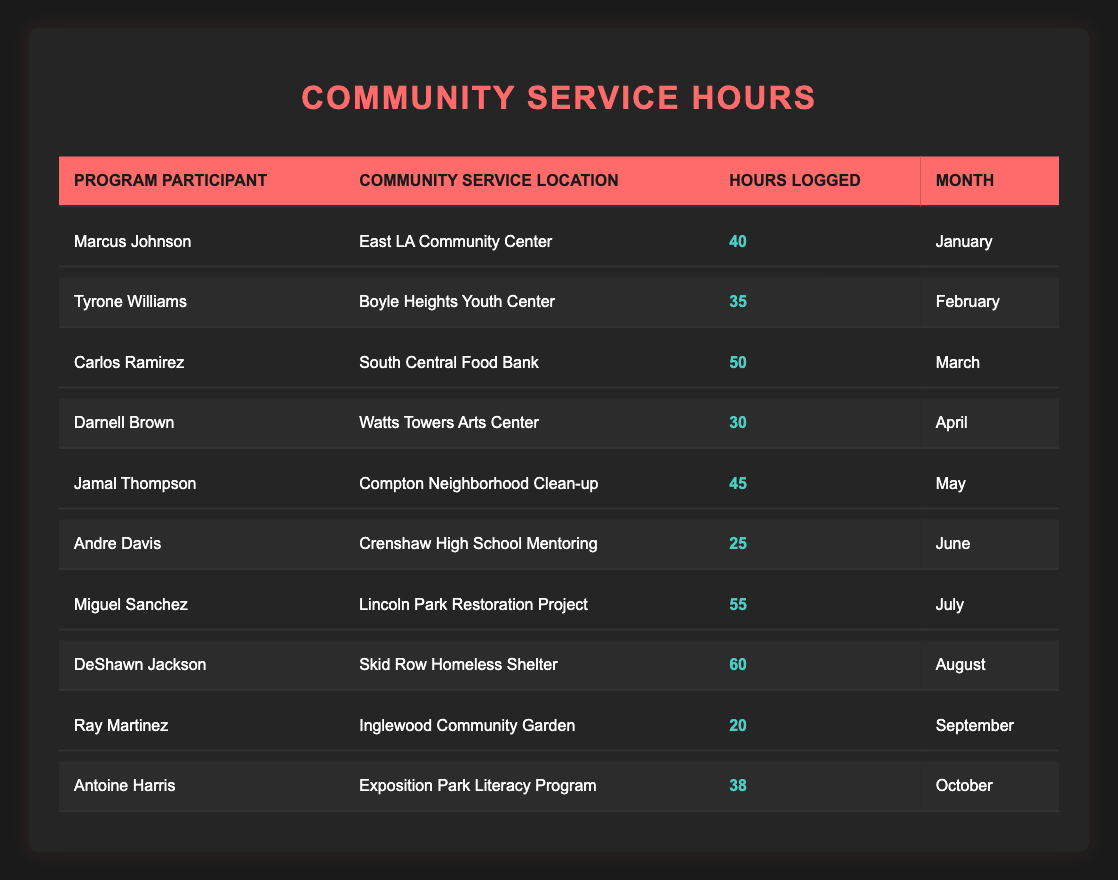What is the total number of community service hours logged by all participants? To find the total number of community service hours, I will add up the hours logged by each participant: 40 + 35 + 50 + 30 + 45 + 25 + 55 + 60 + 20 + 38 =  408.
Answer: 408 Which participant logged the most hours and where did they serve? I will look through the hours logged by each participant to find the maximum value, which is 60 hours logged by DeShawn Jackson at the Skid Row Homeless Shelter.
Answer: DeShawn Jackson at the Skid Row Homeless Shelter How many participants logged hours in July or August? There are two months to consider: July and August. The participants who logged hours in these months are Miguel Sanchez and DeShawn Jackson. So, the total number of participants is 2.
Answer: 2 Did Andre Davis log more than 30 hours? I will check the hours logged by Andre Davis, which is 25 hours. Since 25 is less than 30, the answer is no.
Answer: No What is the average number of community service hours logged by the participants? To calculate the average, I first sum the total hours (408) and then divide it by the number of participants (10). Thus, the average is 408/10 = 40.8.
Answer: 40.8 How many participants volunteered at community service locations associated with food or education? The food-related location is South Central Food Bank, and the education-related location is Crenshaw High School Mentoring and Exposition Park Literacy Program. The participants who volunteered here are Carlos Ramirez, Andre Davis, and Antoine Harris. This totals to 3 participants.
Answer: 3 Which month had the fewest total hours logged and what was that total? I will analyze each month’s hours: January (40), February (35), March (50), April (30), May (45), June (25), July (55), August (60), September (20), October (38). The month with the fewest hours is September with a total of 20 hours.
Answer: September, 20 hours Is it true that more than half of the participants logged 40 hours or more? I will count the participants with 40 hours or more: Marcus Johnson (40), Carlos Ramirez (50), Jamal Thompson (45), Miguel Sanchez (55), DeShawn Jackson (60). There are 5 participants out of 10 who logged 40 hours or more, which is exactly half, so the statement is false.
Answer: No What is the difference between the hours logged by the participant with the most hours and the one with the least hours? The most hours logged is 60 by DeShawn Jackson, and the least is 20 by Ray Martinez. The difference is 60 - 20 = 40.
Answer: 40 